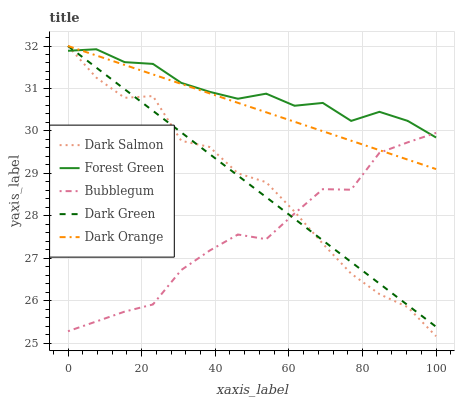Does Dark Salmon have the minimum area under the curve?
Answer yes or no. No. Does Dark Salmon have the maximum area under the curve?
Answer yes or no. No. Is Forest Green the smoothest?
Answer yes or no. No. Is Forest Green the roughest?
Answer yes or no. No. Does Forest Green have the lowest value?
Answer yes or no. No. Does Forest Green have the highest value?
Answer yes or no. No. 